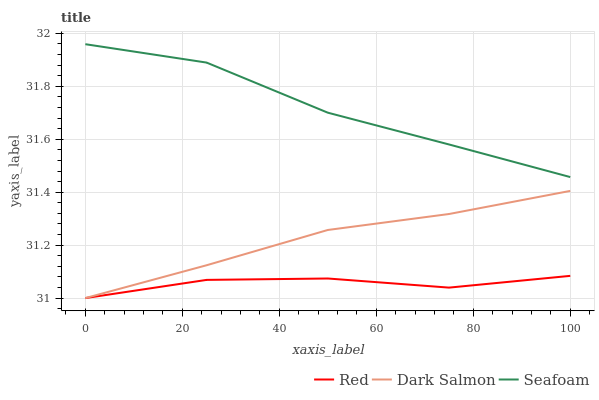Does Red have the minimum area under the curve?
Answer yes or no. Yes. Does Seafoam have the maximum area under the curve?
Answer yes or no. Yes. Does Seafoam have the minimum area under the curve?
Answer yes or no. No. Does Red have the maximum area under the curve?
Answer yes or no. No. Is Dark Salmon the smoothest?
Answer yes or no. Yes. Is Seafoam the roughest?
Answer yes or no. Yes. Is Red the smoothest?
Answer yes or no. No. Is Red the roughest?
Answer yes or no. No. Does Dark Salmon have the lowest value?
Answer yes or no. Yes. Does Seafoam have the lowest value?
Answer yes or no. No. Does Seafoam have the highest value?
Answer yes or no. Yes. Does Red have the highest value?
Answer yes or no. No. Is Dark Salmon less than Seafoam?
Answer yes or no. Yes. Is Seafoam greater than Red?
Answer yes or no. Yes. Does Red intersect Dark Salmon?
Answer yes or no. Yes. Is Red less than Dark Salmon?
Answer yes or no. No. Is Red greater than Dark Salmon?
Answer yes or no. No. Does Dark Salmon intersect Seafoam?
Answer yes or no. No. 